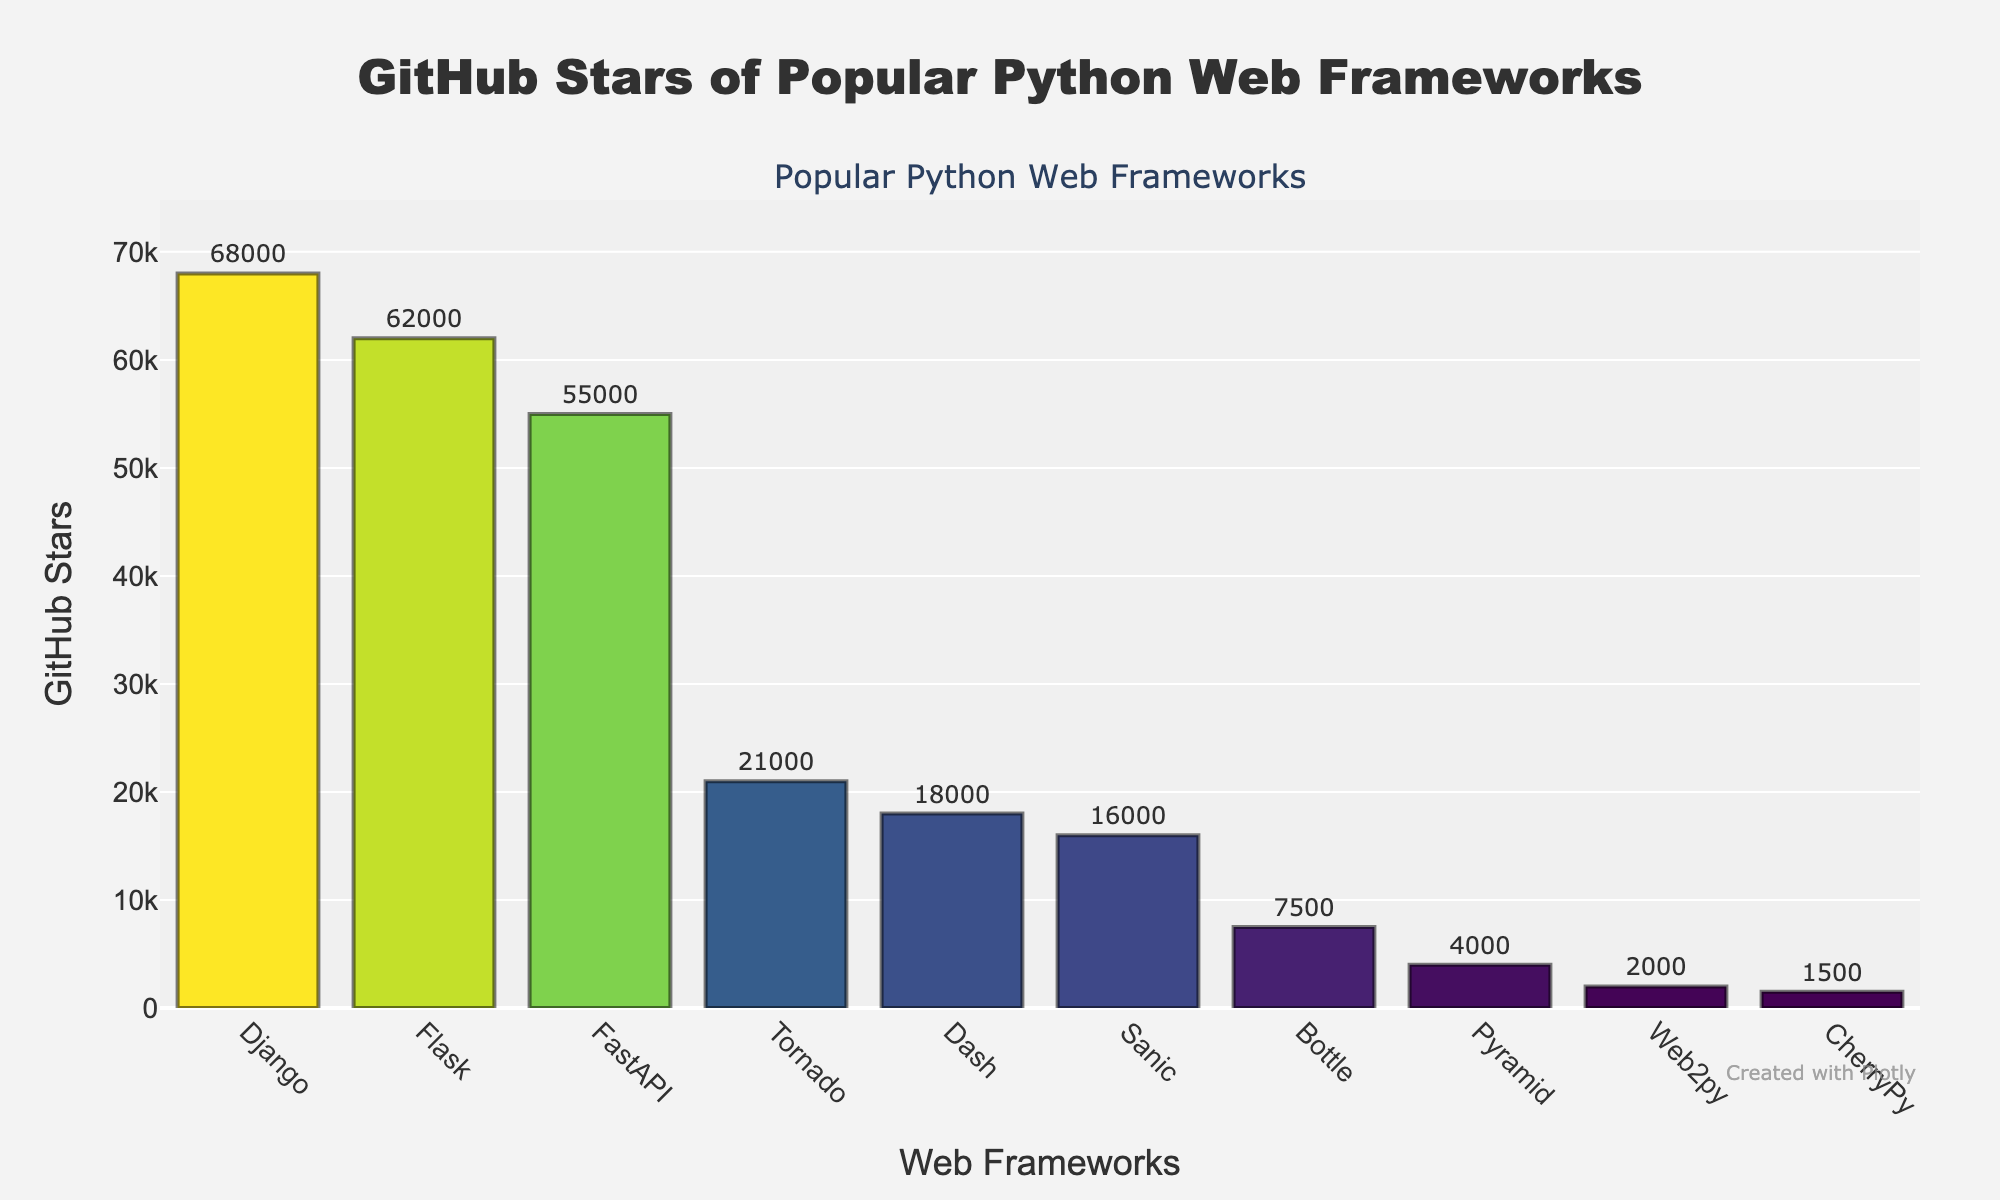What's the most popular Python web framework based on GitHub stars? The most popular framework can be identified by examining which bar reaches the highest point on the chart. Django's bar is the tallest.
Answer: Django Which framework has the least GitHub stars? The framework with the shortest bar represents the one with the least GitHub stars, which is CherryPy.
Answer: CherryPy What is the difference in GitHub stars between Flask and Tornado? Look at the heights of the bars for Flask and Tornado. Flask has 62000 stars, and Tornado has 21000 stars. Subtract the two values: 62000 - 21000 = 41000.
Answer: 41000 Compare the number of stars between FastAPI and Sanic. Which one has more stars and by how much? FastAPI has 55000 stars, and Sanic has 16000 stars. FastAPI has more stars. The difference is 55000 - 16000 = 39000.
Answer: FastAPI by 39000 What's the total number of GitHub stars for Bottle and Pyramid combined? Sum the stars for Bottle (7500) and Pyramid (4000). 7500 + 4000 = 11500.
Answer: 11500 How does Django's GitHub stars compare to all other frameworks combined? First, sum the stars of all other frameworks: Flask (62000) + FastAPI (55000) + Pyramid (4000) + Bottle (7500) + Tornado (21000) + Sanic (16000) + CherryPy (1500) + Dash (18000) + Web2py (2000) = 173000. Compare Django's 68000 stars to 173000. Django's stars are less.
Answer: Less Which frameworks have more than 20000 GitHub stars? Identify the bars higher than the 20000 mark: Django, Flask, FastAPI, and Tornado.
Answer: Django, Flask, FastAPI, Tornado What's the average number of GitHub stars across all frameworks? Sum the stars for all frameworks: 68000 + 62000 + 55000 + 4000 + 7500 + 21000 + 16000 + 1500 + 18000 + 2000 = 255000. Divide by the number of frameworks, which is 10. 255000 / 10 = 25500.
Answer: 25500 How many frameworks have fewer than 10000 GitHub stars? Count the bars that are below the 10000 mark: Pyramid, Bottle, CherryPy, and Web2py. There are 4 such frameworks.
Answer: 4 What is the ratio of the GitHub stars between the most popular (Django) and the least popular (CherryPy)? Django has 68000 stars, and CherryPy has 1500 stars. The ratio is 68000 / 1500 ≈ 45.33.
Answer: 45.33 